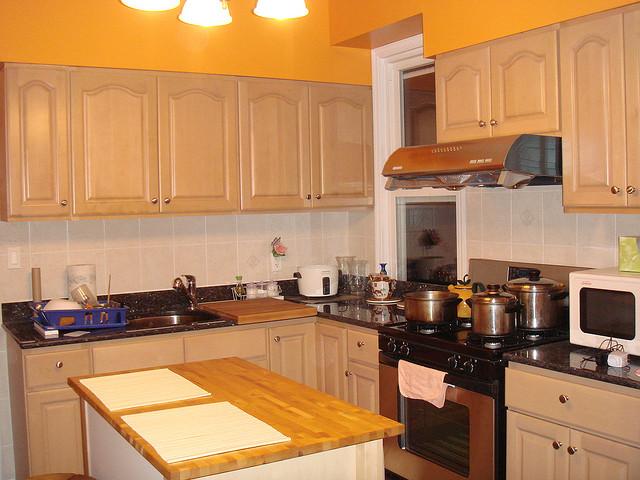Is the stove gas or electric?
Be succinct. Gas. Does the kitchen have an island?
Be succinct. Yes. Is something cooking?
Short answer required. Yes. 